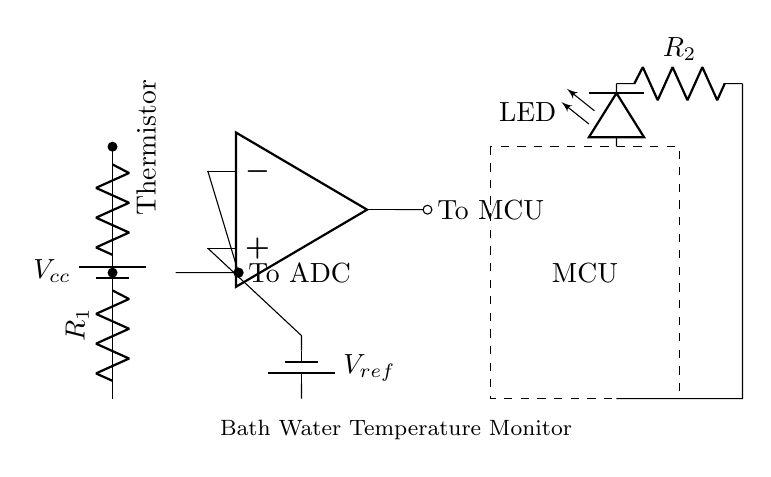What is the power supply voltage for this circuit? The circuit receives power from a battery, indicated by the label Vcc. The specific voltage isn't given in the diagram, but it's a crucial component that determines the operational limits of the circuit.
Answer: Vcc What component measures the water temperature? The component used to measure temperature in this circuit is the thermistor, which changes its resistance with temperature variations. It is labeled accordingly in the diagram.
Answer: Thermistor How many resistors are present in this circuit? There are two resistors depicted in this circuit: one is the thermistor and the other is labeled R1. Although R2 is also present for the LED, it is connected in a different part of the circuit.
Answer: Two What is the output from the operational amplifier? The output from the operational amplifier is shown to be connected and labeled as "To MCU." It processes the signal and sends it for further analysis or alerts.
Answer: To MCU What does the LED indicate in this circuit? The LED serves as an indicator that signals when the bath water temperature is within a safe range. The circuit isn't specified further, but it typically lights up based on conditions monitored by the MCU.
Answer: Safe temperature indication How does the voltage divider function in this circuit? In this circuit, the voltage divider is formed by the thermistor and resistor R1. It outputs a varying voltage depending on the resistance of the thermistor, which changes with temperature, allowing the ADC to read the temperature.
Answer: Varies with temperature What does MCU stand for in this circuit? MCU stands for Microcontroller Unit, which is the core processing unit that receives inputs from the circuit and determines the actions based on the temperature readings to ensure safety.
Answer: Microcontroller Unit 